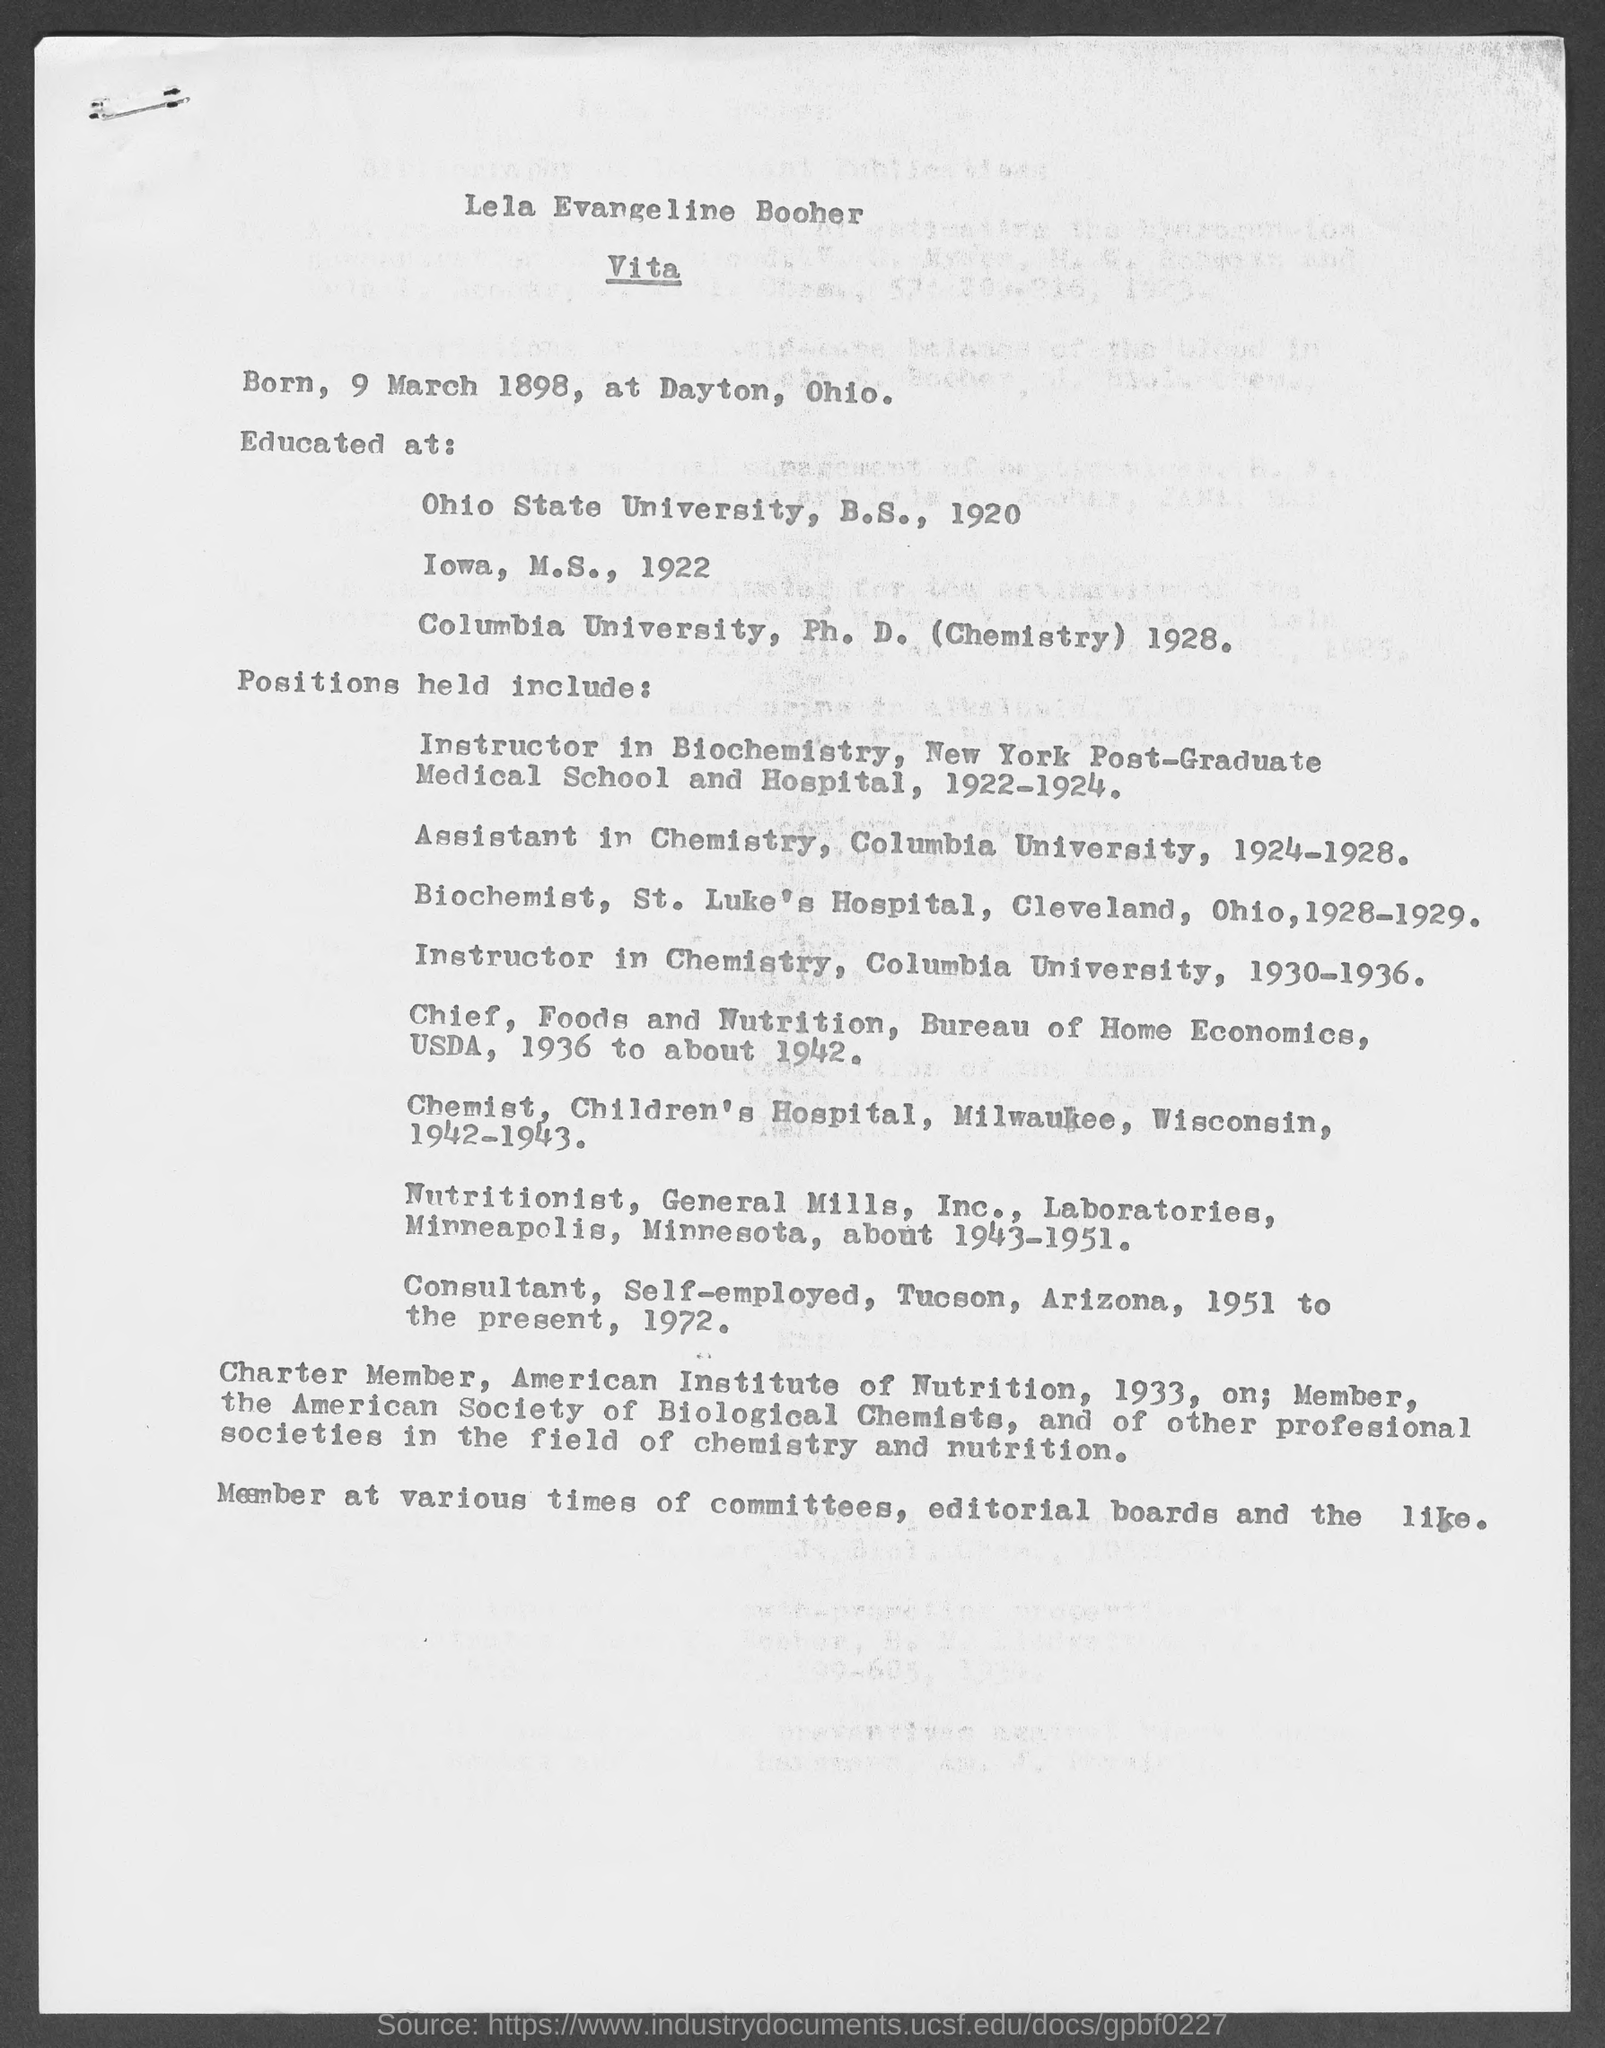Point out several critical features in this image. Lela Evangeline Booher was born on March 9, 1898. Lela Evangeline Booher has obtained a Ph.D. from Columbia University. During the period of 1922-1924, Lela Evangeline Booher held the position of Instructor in Biochemistry. Lela Evangeline Booher worked as an Instructor in Chemistry during the period of 1930-1936. Lela Evangeline Booher served as an Assistant in Chemistry at Columbia University from 1924 to 1928. 